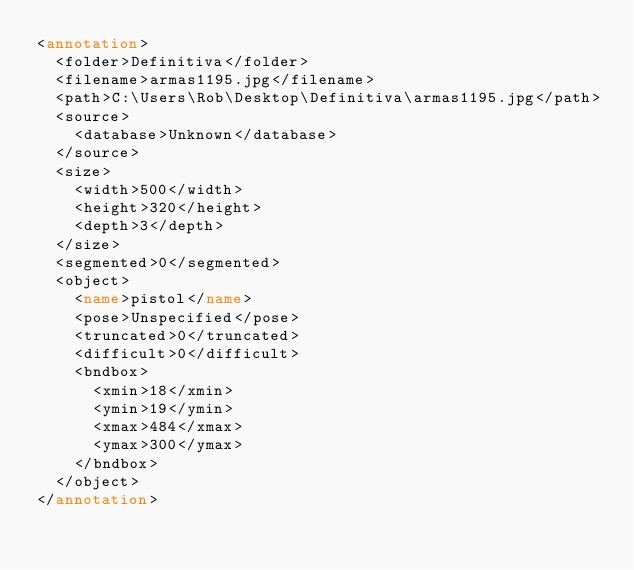<code> <loc_0><loc_0><loc_500><loc_500><_XML_><annotation>
  <folder>Definitiva</folder>
  <filename>armas1195.jpg</filename>
  <path>C:\Users\Rob\Desktop\Definitiva\armas1195.jpg</path>
  <source>
    <database>Unknown</database>
  </source>
  <size>
    <width>500</width>
    <height>320</height>
    <depth>3</depth>
  </size>
  <segmented>0</segmented>
  <object>
    <name>pistol</name>
    <pose>Unspecified</pose>
    <truncated>0</truncated>
    <difficult>0</difficult>
    <bndbox>
      <xmin>18</xmin>
      <ymin>19</ymin>
      <xmax>484</xmax>
      <ymax>300</ymax>
    </bndbox>
  </object>
</annotation>
</code> 